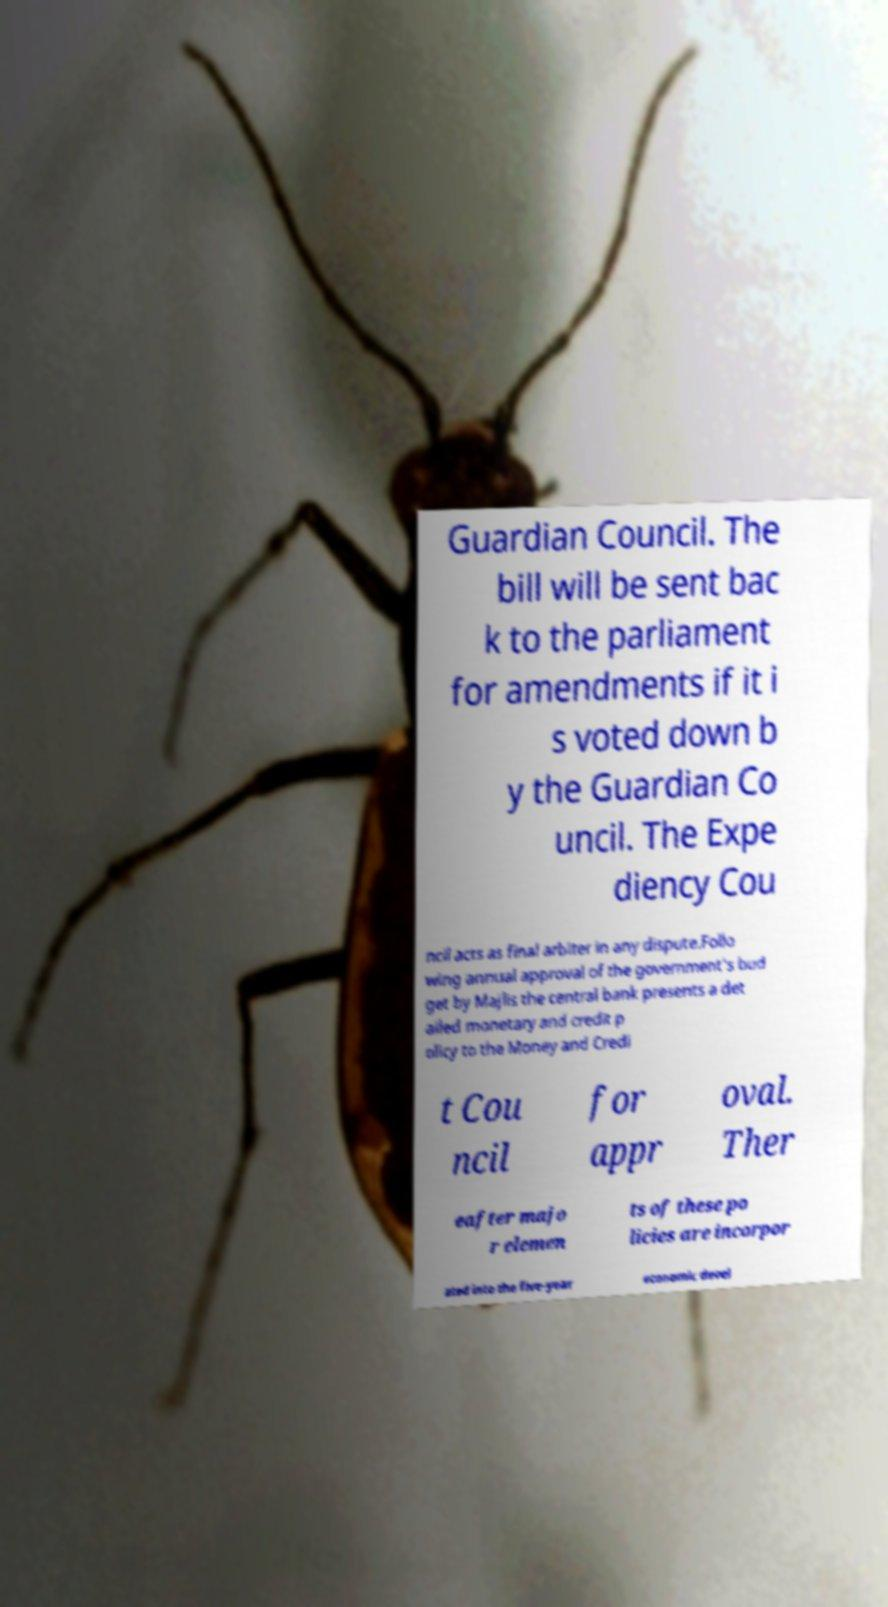Can you accurately transcribe the text from the provided image for me? Guardian Council. The bill will be sent bac k to the parliament for amendments if it i s voted down b y the Guardian Co uncil. The Expe diency Cou ncil acts as final arbiter in any dispute.Follo wing annual approval of the government's bud get by Majlis the central bank presents a det ailed monetary and credit p olicy to the Money and Credi t Cou ncil for appr oval. Ther eafter majo r elemen ts of these po licies are incorpor ated into the five-year economic devel 